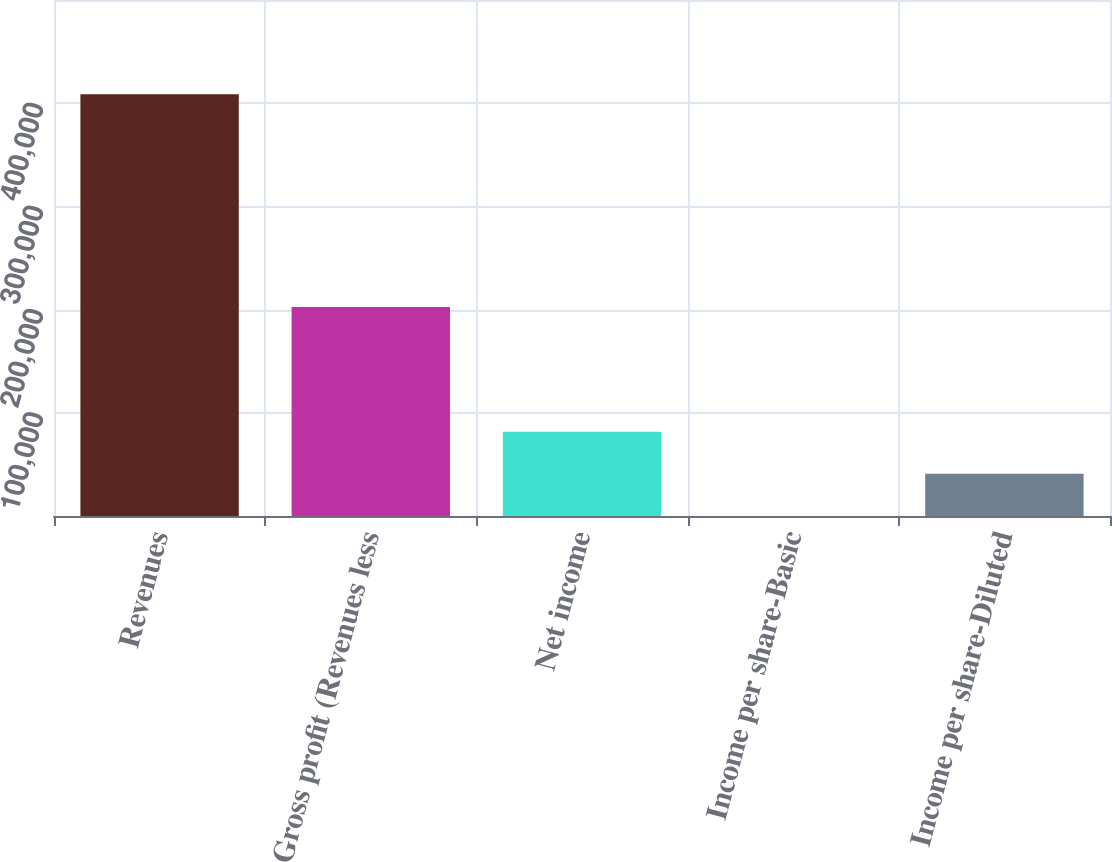<chart> <loc_0><loc_0><loc_500><loc_500><bar_chart><fcel>Revenues<fcel>Gross profit (Revenues less<fcel>Net income<fcel>Income per share-Basic<fcel>Income per share-Diluted<nl><fcel>408742<fcel>202599<fcel>81748.5<fcel>0.15<fcel>40874.3<nl></chart> 